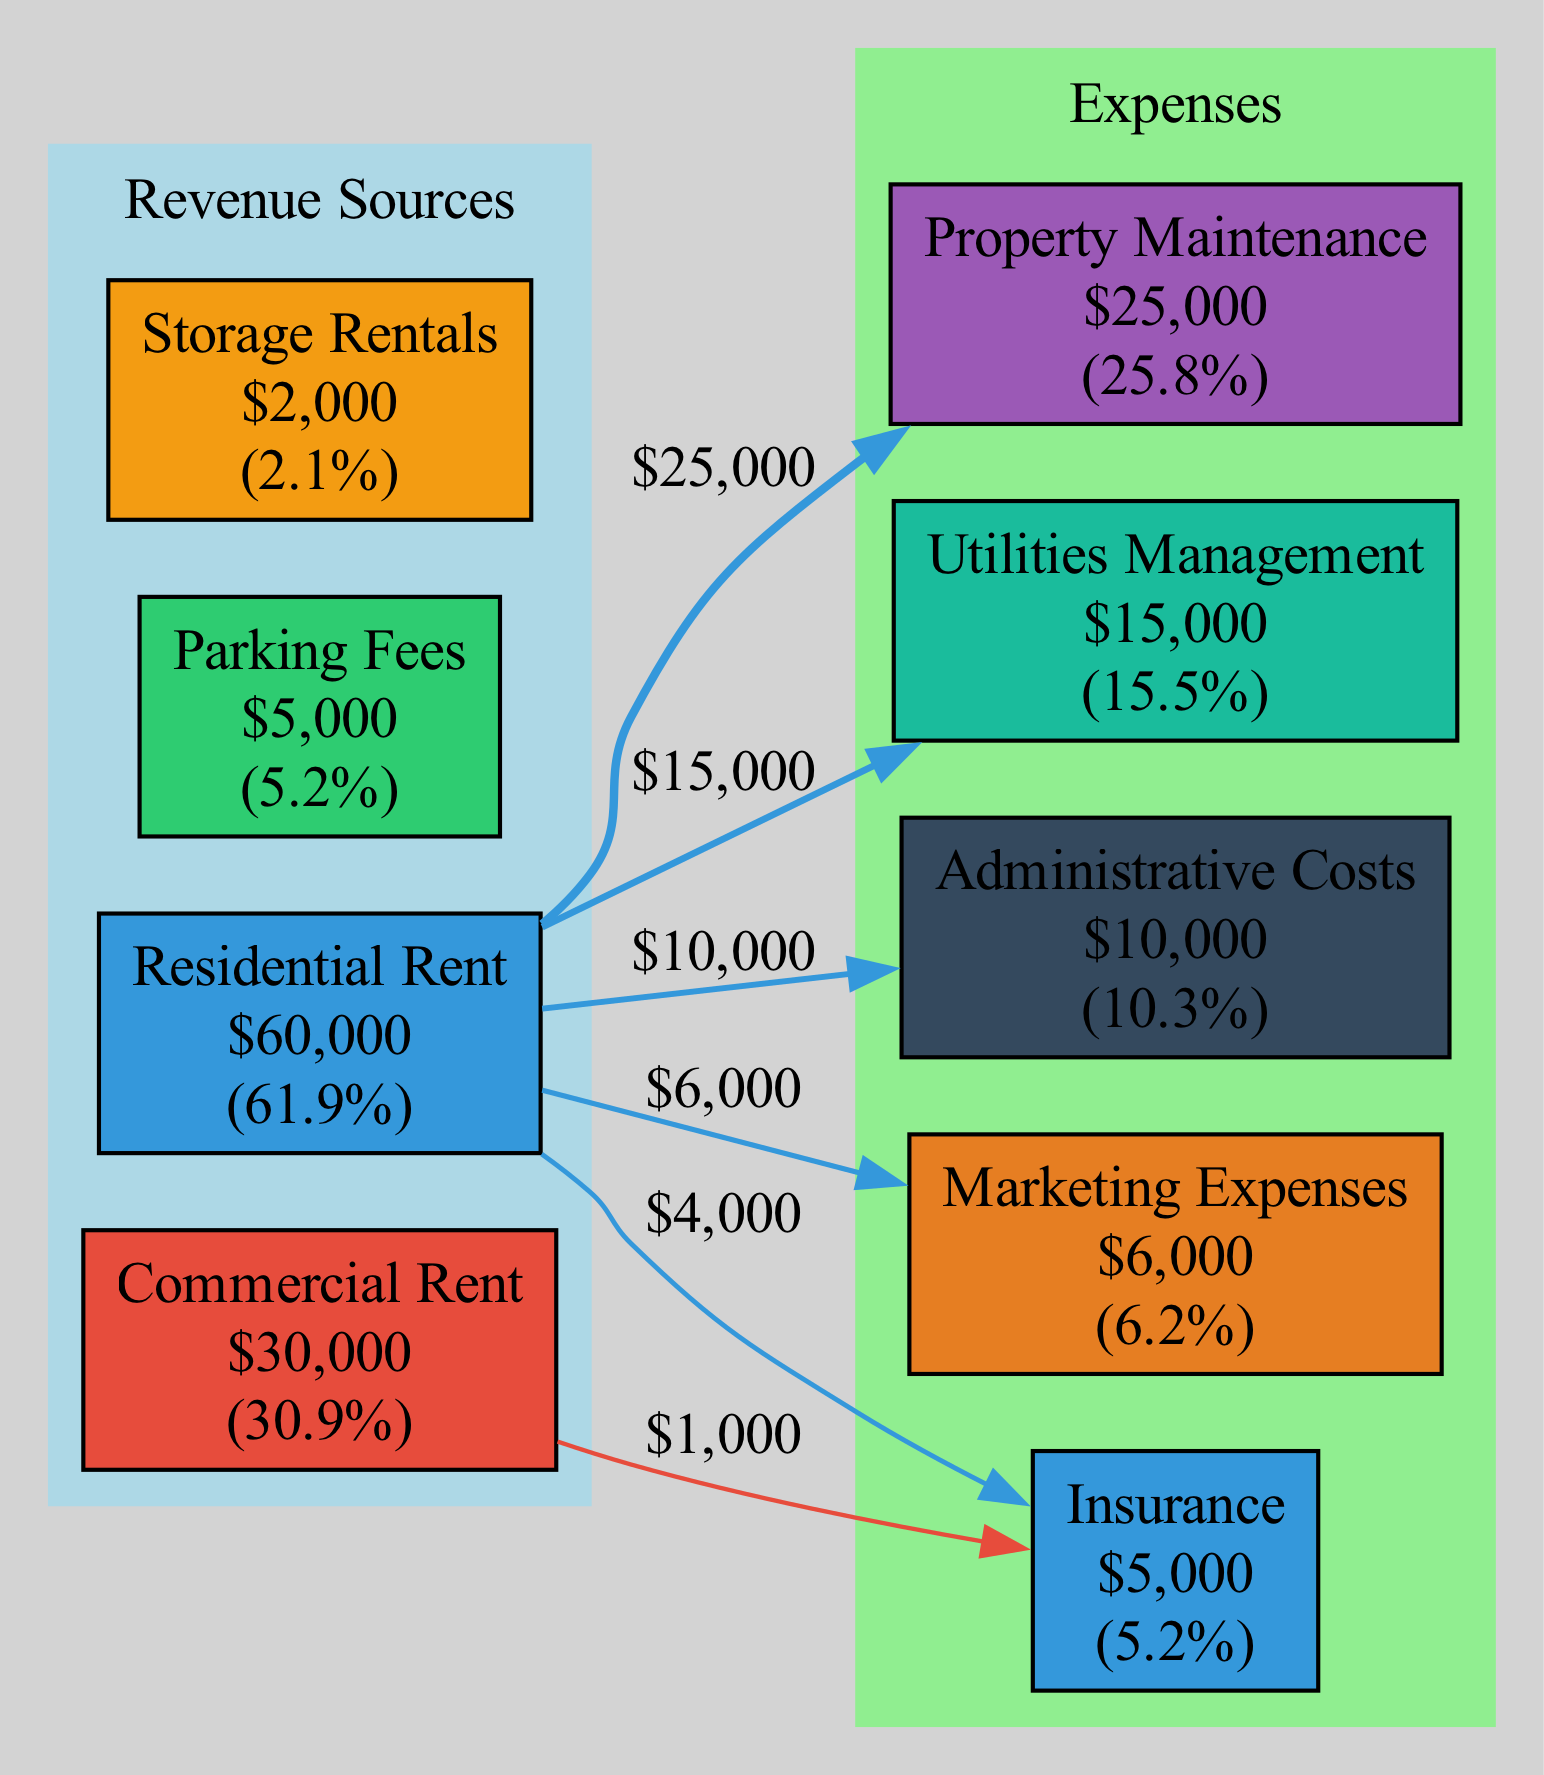What is the total monthly rent collected from Residential Rent? The diagram shows the amount labeled under "Residential Rent," which is $60,000. This amount directly represents the total rent collected from residential sources.
Answer: $60,000 How much is allocated to Property Maintenance? The diagram indicates that the amount directed towards "Property Maintenance" is $25,000, as labeled in that expense node.
Answer: $25,000 What percentage of the total revenue comes from Commercial Rent? To find this percentage, divide the amount from "Commercial Rent" ($30,000) by the total revenue ($95,000) and multiply by 100, resulting in approximately 31.6%. This percentage is labeled with the Commercial Rent node.
Answer: 31.6% Which source contributes the least amount to the monthly revenue? The diagram displays the amounts for each source, and "Storage Rentals" shows the least amount at $2,000, making it the smallest contributor.
Answer: Storage Rentals What is the total amount allocated to Administrative Costs and Marketing Expenses combined? The amounts for "Administrative Costs" ($10,000) and "Marketing Expenses" ($6,000) can be summed to find the total allocated: $10,000 + $6,000 = $16,000. This combines the values presented in their respective expense nodes.
Answer: $16,000 How many sources of revenue are displayed in the diagram? The diagram includes four nodes listed as sources: "Residential Rent," "Commercial Rent," "Parking Fees," and "Storage Rentals," making a total of four sources.
Answer: 4 From which source does the highest amount flow to Insurance? Analyzing the edges flowing into "Insurance," it can be observed that "Residential Rent" contributes the highest amount, evidenced by the thickness of the edge leading to the Insurance node relative to others.
Answer: Residential Rent What is the total revenue shown in the diagram? The total revenue is derived from adding all the individual sources: $60,000 (Residential Rent) + $30,000 (Commercial Rent) + $5,000 (Parking Fees) + $2,000 (Storage Rentals) = $97,000. This total is inferred from the sums of each source's amounts.
Answer: $97,000 